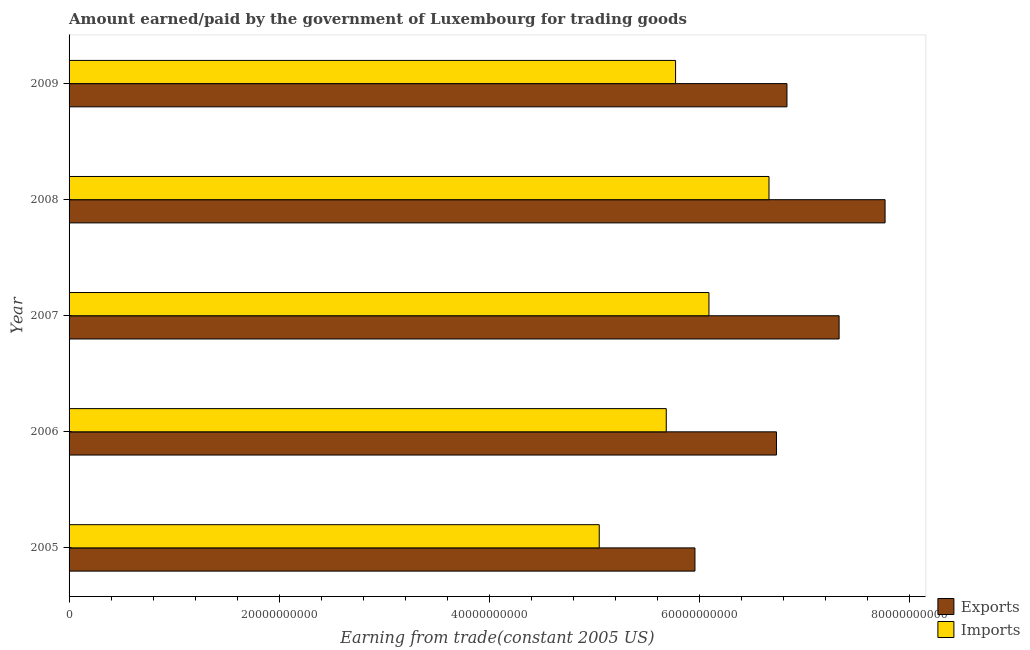Are the number of bars on each tick of the Y-axis equal?
Provide a short and direct response. Yes. How many bars are there on the 4th tick from the top?
Make the answer very short. 2. What is the label of the 1st group of bars from the top?
Keep it short and to the point. 2009. In how many cases, is the number of bars for a given year not equal to the number of legend labels?
Provide a succinct answer. 0. What is the amount earned from exports in 2008?
Provide a succinct answer. 7.77e+1. Across all years, what is the maximum amount paid for imports?
Keep it short and to the point. 6.66e+1. Across all years, what is the minimum amount earned from exports?
Give a very brief answer. 5.96e+1. In which year was the amount earned from exports maximum?
Offer a terse response. 2008. What is the total amount paid for imports in the graph?
Your response must be concise. 2.93e+11. What is the difference between the amount paid for imports in 2006 and that in 2009?
Give a very brief answer. -8.87e+08. What is the difference between the amount paid for imports in 2009 and the amount earned from exports in 2005?
Keep it short and to the point. -1.84e+09. What is the average amount earned from exports per year?
Ensure brevity in your answer.  6.92e+1. In the year 2007, what is the difference between the amount paid for imports and amount earned from exports?
Ensure brevity in your answer.  -1.24e+1. In how many years, is the amount paid for imports greater than 16000000000 US$?
Your answer should be very brief. 5. What is the ratio of the amount earned from exports in 2005 to that in 2006?
Your response must be concise. 0.89. Is the difference between the amount paid for imports in 2005 and 2009 greater than the difference between the amount earned from exports in 2005 and 2009?
Give a very brief answer. Yes. What is the difference between the highest and the second highest amount paid for imports?
Ensure brevity in your answer.  5.71e+09. What is the difference between the highest and the lowest amount paid for imports?
Offer a very short reply. 1.62e+1. In how many years, is the amount earned from exports greater than the average amount earned from exports taken over all years?
Your response must be concise. 2. Is the sum of the amount paid for imports in 2007 and 2009 greater than the maximum amount earned from exports across all years?
Provide a short and direct response. Yes. What does the 2nd bar from the top in 2005 represents?
Provide a short and direct response. Exports. What does the 1st bar from the bottom in 2005 represents?
Provide a succinct answer. Exports. Are all the bars in the graph horizontal?
Your response must be concise. Yes. How many years are there in the graph?
Make the answer very short. 5. What is the difference between two consecutive major ticks on the X-axis?
Your answer should be compact. 2.00e+1. Are the values on the major ticks of X-axis written in scientific E-notation?
Provide a short and direct response. No. Does the graph contain grids?
Offer a very short reply. No. Where does the legend appear in the graph?
Offer a terse response. Bottom right. How are the legend labels stacked?
Offer a terse response. Vertical. What is the title of the graph?
Provide a short and direct response. Amount earned/paid by the government of Luxembourg for trading goods. What is the label or title of the X-axis?
Provide a succinct answer. Earning from trade(constant 2005 US). What is the label or title of the Y-axis?
Provide a short and direct response. Year. What is the Earning from trade(constant 2005 US) of Exports in 2005?
Your response must be concise. 5.96e+1. What is the Earning from trade(constant 2005 US) in Imports in 2005?
Your answer should be very brief. 5.05e+1. What is the Earning from trade(constant 2005 US) in Exports in 2006?
Keep it short and to the point. 6.73e+1. What is the Earning from trade(constant 2005 US) of Imports in 2006?
Your answer should be very brief. 5.68e+1. What is the Earning from trade(constant 2005 US) in Exports in 2007?
Give a very brief answer. 7.33e+1. What is the Earning from trade(constant 2005 US) of Imports in 2007?
Your response must be concise. 6.09e+1. What is the Earning from trade(constant 2005 US) of Exports in 2008?
Make the answer very short. 7.77e+1. What is the Earning from trade(constant 2005 US) in Imports in 2008?
Give a very brief answer. 6.66e+1. What is the Earning from trade(constant 2005 US) of Exports in 2009?
Your response must be concise. 6.83e+1. What is the Earning from trade(constant 2005 US) of Imports in 2009?
Make the answer very short. 5.77e+1. Across all years, what is the maximum Earning from trade(constant 2005 US) of Exports?
Ensure brevity in your answer.  7.77e+1. Across all years, what is the maximum Earning from trade(constant 2005 US) in Imports?
Your answer should be very brief. 6.66e+1. Across all years, what is the minimum Earning from trade(constant 2005 US) in Exports?
Ensure brevity in your answer.  5.96e+1. Across all years, what is the minimum Earning from trade(constant 2005 US) of Imports?
Provide a succinct answer. 5.05e+1. What is the total Earning from trade(constant 2005 US) in Exports in the graph?
Provide a succinct answer. 3.46e+11. What is the total Earning from trade(constant 2005 US) in Imports in the graph?
Keep it short and to the point. 2.93e+11. What is the difference between the Earning from trade(constant 2005 US) in Exports in 2005 and that in 2006?
Offer a terse response. -7.76e+09. What is the difference between the Earning from trade(constant 2005 US) in Imports in 2005 and that in 2006?
Ensure brevity in your answer.  -6.38e+09. What is the difference between the Earning from trade(constant 2005 US) in Exports in 2005 and that in 2007?
Provide a succinct answer. -1.37e+1. What is the difference between the Earning from trade(constant 2005 US) in Imports in 2005 and that in 2007?
Your answer should be compact. -1.04e+1. What is the difference between the Earning from trade(constant 2005 US) in Exports in 2005 and that in 2008?
Your answer should be very brief. -1.81e+1. What is the difference between the Earning from trade(constant 2005 US) in Imports in 2005 and that in 2008?
Provide a succinct answer. -1.62e+1. What is the difference between the Earning from trade(constant 2005 US) in Exports in 2005 and that in 2009?
Keep it short and to the point. -8.76e+09. What is the difference between the Earning from trade(constant 2005 US) in Imports in 2005 and that in 2009?
Keep it short and to the point. -7.27e+09. What is the difference between the Earning from trade(constant 2005 US) of Exports in 2006 and that in 2007?
Make the answer very short. -5.96e+09. What is the difference between the Earning from trade(constant 2005 US) in Imports in 2006 and that in 2007?
Make the answer very short. -4.06e+09. What is the difference between the Earning from trade(constant 2005 US) of Exports in 2006 and that in 2008?
Your answer should be very brief. -1.03e+1. What is the difference between the Earning from trade(constant 2005 US) in Imports in 2006 and that in 2008?
Offer a terse response. -9.78e+09. What is the difference between the Earning from trade(constant 2005 US) in Exports in 2006 and that in 2009?
Provide a short and direct response. -9.99e+08. What is the difference between the Earning from trade(constant 2005 US) in Imports in 2006 and that in 2009?
Your answer should be compact. -8.87e+08. What is the difference between the Earning from trade(constant 2005 US) of Exports in 2007 and that in 2008?
Your answer should be compact. -4.38e+09. What is the difference between the Earning from trade(constant 2005 US) of Imports in 2007 and that in 2008?
Make the answer very short. -5.71e+09. What is the difference between the Earning from trade(constant 2005 US) in Exports in 2007 and that in 2009?
Give a very brief answer. 4.96e+09. What is the difference between the Earning from trade(constant 2005 US) in Imports in 2007 and that in 2009?
Your answer should be very brief. 3.18e+09. What is the difference between the Earning from trade(constant 2005 US) of Exports in 2008 and that in 2009?
Your response must be concise. 9.34e+09. What is the difference between the Earning from trade(constant 2005 US) of Imports in 2008 and that in 2009?
Your answer should be very brief. 8.89e+09. What is the difference between the Earning from trade(constant 2005 US) in Exports in 2005 and the Earning from trade(constant 2005 US) in Imports in 2006?
Provide a short and direct response. 2.73e+09. What is the difference between the Earning from trade(constant 2005 US) of Exports in 2005 and the Earning from trade(constant 2005 US) of Imports in 2007?
Keep it short and to the point. -1.33e+09. What is the difference between the Earning from trade(constant 2005 US) of Exports in 2005 and the Earning from trade(constant 2005 US) of Imports in 2008?
Keep it short and to the point. -7.05e+09. What is the difference between the Earning from trade(constant 2005 US) of Exports in 2005 and the Earning from trade(constant 2005 US) of Imports in 2009?
Your response must be concise. 1.84e+09. What is the difference between the Earning from trade(constant 2005 US) of Exports in 2006 and the Earning from trade(constant 2005 US) of Imports in 2007?
Your answer should be very brief. 6.43e+09. What is the difference between the Earning from trade(constant 2005 US) of Exports in 2006 and the Earning from trade(constant 2005 US) of Imports in 2008?
Offer a very short reply. 7.11e+08. What is the difference between the Earning from trade(constant 2005 US) in Exports in 2006 and the Earning from trade(constant 2005 US) in Imports in 2009?
Provide a short and direct response. 9.60e+09. What is the difference between the Earning from trade(constant 2005 US) of Exports in 2007 and the Earning from trade(constant 2005 US) of Imports in 2008?
Your answer should be compact. 6.67e+09. What is the difference between the Earning from trade(constant 2005 US) in Exports in 2007 and the Earning from trade(constant 2005 US) in Imports in 2009?
Make the answer very short. 1.56e+1. What is the difference between the Earning from trade(constant 2005 US) in Exports in 2008 and the Earning from trade(constant 2005 US) in Imports in 2009?
Provide a succinct answer. 1.99e+1. What is the average Earning from trade(constant 2005 US) of Exports per year?
Provide a short and direct response. 6.92e+1. What is the average Earning from trade(constant 2005 US) of Imports per year?
Make the answer very short. 5.85e+1. In the year 2005, what is the difference between the Earning from trade(constant 2005 US) in Exports and Earning from trade(constant 2005 US) in Imports?
Your answer should be compact. 9.11e+09. In the year 2006, what is the difference between the Earning from trade(constant 2005 US) of Exports and Earning from trade(constant 2005 US) of Imports?
Your answer should be compact. 1.05e+1. In the year 2007, what is the difference between the Earning from trade(constant 2005 US) in Exports and Earning from trade(constant 2005 US) in Imports?
Your answer should be very brief. 1.24e+1. In the year 2008, what is the difference between the Earning from trade(constant 2005 US) in Exports and Earning from trade(constant 2005 US) in Imports?
Offer a terse response. 1.10e+1. In the year 2009, what is the difference between the Earning from trade(constant 2005 US) of Exports and Earning from trade(constant 2005 US) of Imports?
Keep it short and to the point. 1.06e+1. What is the ratio of the Earning from trade(constant 2005 US) in Exports in 2005 to that in 2006?
Your answer should be very brief. 0.88. What is the ratio of the Earning from trade(constant 2005 US) of Imports in 2005 to that in 2006?
Give a very brief answer. 0.89. What is the ratio of the Earning from trade(constant 2005 US) in Exports in 2005 to that in 2007?
Your response must be concise. 0.81. What is the ratio of the Earning from trade(constant 2005 US) in Imports in 2005 to that in 2007?
Your answer should be compact. 0.83. What is the ratio of the Earning from trade(constant 2005 US) in Exports in 2005 to that in 2008?
Provide a short and direct response. 0.77. What is the ratio of the Earning from trade(constant 2005 US) in Imports in 2005 to that in 2008?
Your answer should be compact. 0.76. What is the ratio of the Earning from trade(constant 2005 US) of Exports in 2005 to that in 2009?
Keep it short and to the point. 0.87. What is the ratio of the Earning from trade(constant 2005 US) of Imports in 2005 to that in 2009?
Provide a short and direct response. 0.87. What is the ratio of the Earning from trade(constant 2005 US) of Exports in 2006 to that in 2007?
Provide a succinct answer. 0.92. What is the ratio of the Earning from trade(constant 2005 US) of Exports in 2006 to that in 2008?
Your response must be concise. 0.87. What is the ratio of the Earning from trade(constant 2005 US) in Imports in 2006 to that in 2008?
Your answer should be very brief. 0.85. What is the ratio of the Earning from trade(constant 2005 US) in Exports in 2006 to that in 2009?
Make the answer very short. 0.99. What is the ratio of the Earning from trade(constant 2005 US) of Imports in 2006 to that in 2009?
Keep it short and to the point. 0.98. What is the ratio of the Earning from trade(constant 2005 US) of Exports in 2007 to that in 2008?
Ensure brevity in your answer.  0.94. What is the ratio of the Earning from trade(constant 2005 US) of Imports in 2007 to that in 2008?
Keep it short and to the point. 0.91. What is the ratio of the Earning from trade(constant 2005 US) in Exports in 2007 to that in 2009?
Provide a short and direct response. 1.07. What is the ratio of the Earning from trade(constant 2005 US) of Imports in 2007 to that in 2009?
Provide a succinct answer. 1.05. What is the ratio of the Earning from trade(constant 2005 US) of Exports in 2008 to that in 2009?
Offer a very short reply. 1.14. What is the ratio of the Earning from trade(constant 2005 US) in Imports in 2008 to that in 2009?
Give a very brief answer. 1.15. What is the difference between the highest and the second highest Earning from trade(constant 2005 US) of Exports?
Offer a terse response. 4.38e+09. What is the difference between the highest and the second highest Earning from trade(constant 2005 US) of Imports?
Keep it short and to the point. 5.71e+09. What is the difference between the highest and the lowest Earning from trade(constant 2005 US) of Exports?
Your response must be concise. 1.81e+1. What is the difference between the highest and the lowest Earning from trade(constant 2005 US) of Imports?
Offer a terse response. 1.62e+1. 